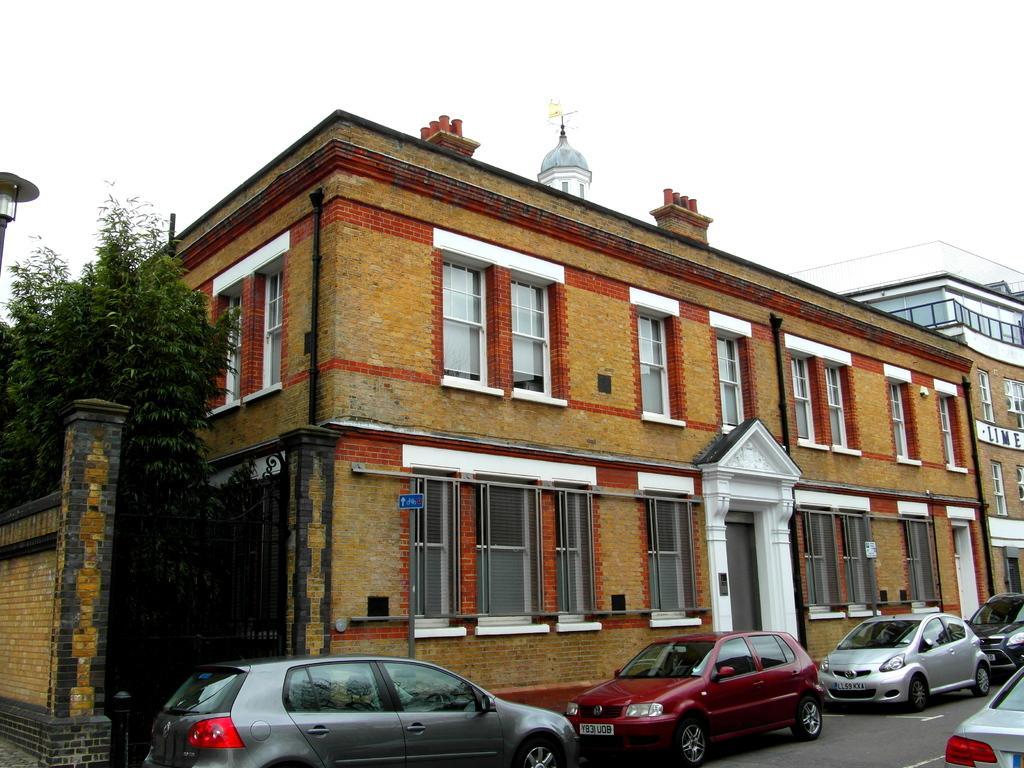How would you summarize this image in a sentence or two? This image is clicked on the road. There are many cars parked on the road. Behind the cars there are buildings. At the top there is the sky. To the left there are trees. 